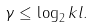Convert formula to latex. <formula><loc_0><loc_0><loc_500><loc_500>\gamma \leq \log _ { 2 } k l .</formula> 